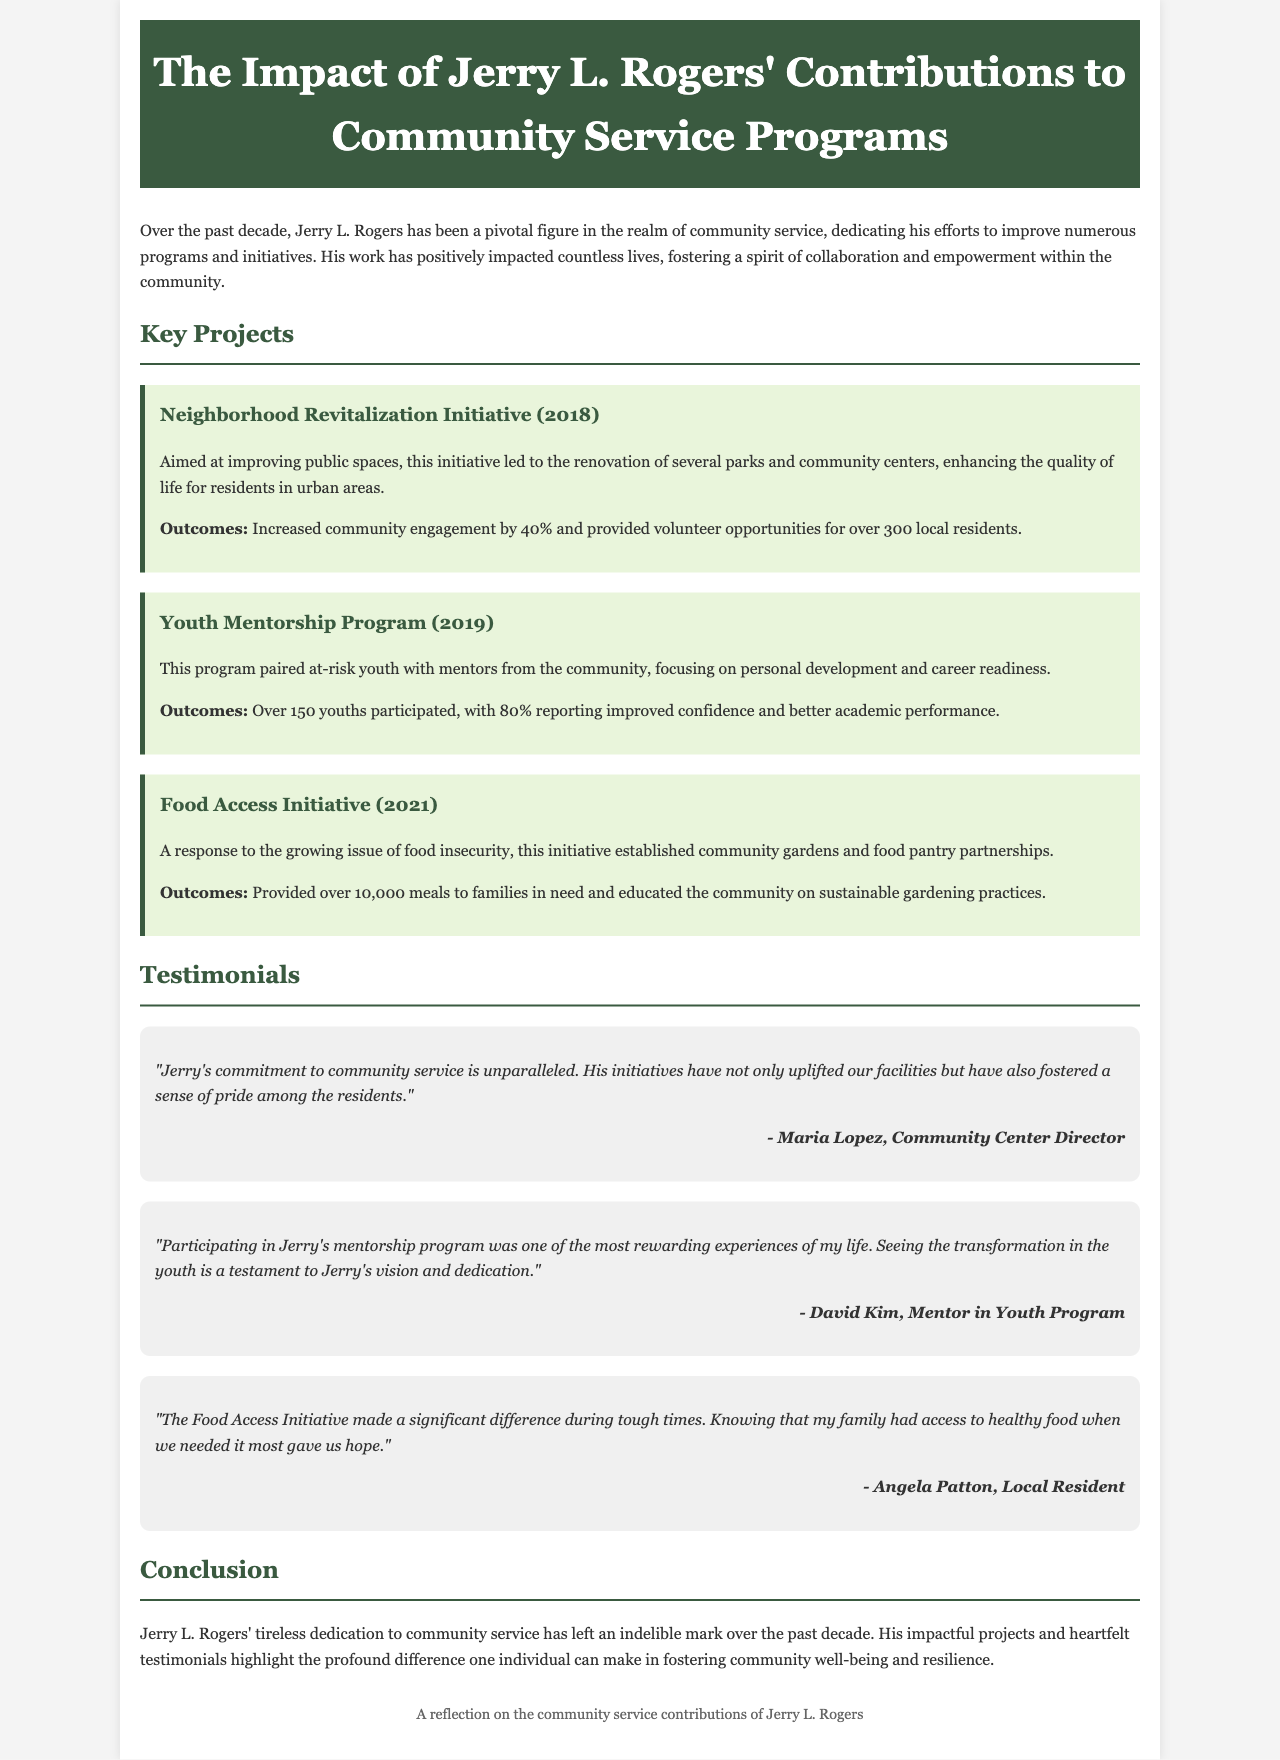What year was the Neighborhood Revitalization Initiative launched? The document states that the Neighborhood Revitalization Initiative was launched in 2018.
Answer: 2018 How many local residents participated in the Youth Mentorship Program? The document mentions that over 150 youths participated in the Youth Mentorship Program.
Answer: Over 150 What percentage of participants in the Youth Mentorship Program reported improved confidence? According to the document, 80% of participants reported improved confidence.
Answer: 80% How many meals were provided through the Food Access Initiative? The document states that the Food Access Initiative provided over 10,000 meals to families in need.
Answer: Over 10,000 Who is quoted as saying Jerry's initiatives have uplifted community facilities? The document attributes the quote praising Jerry's initiatives to Maria Lopez, Community Center Director.
Answer: Maria Lopez What is the primary focus of the Youth Mentorship Program? The document describes the primary focus of the Youth Mentorship Program as personal development and career readiness.
Answer: Personal development and career readiness What is highlighted as a significant outcome of the Neighborhood Revitalization Initiative? Increased community engagement by 40% is highlighted as a significant outcome of the Neighborhood Revitalization Initiative.
Answer: Increased community engagement by 40% How does the Food Access Initiative educate the community? The document explains that the Food Access Initiative educates the community on sustainable gardening practices.
Answer: Sustainable gardening practices What sentiment does Angela Patton express about the Food Access Initiative? Angela Patton expresses that having access to healthy food during tough times gave her family hope.
Answer: Gave us hope 